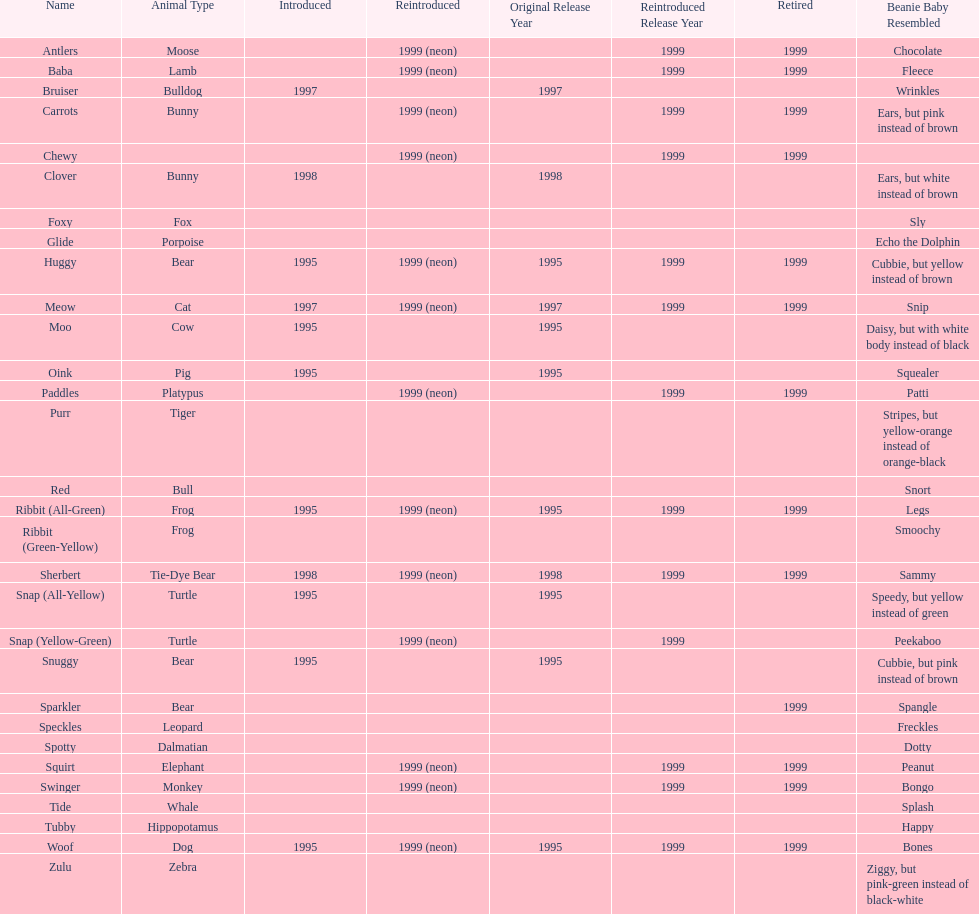What are the total number of pillow pals on this chart? 30. 